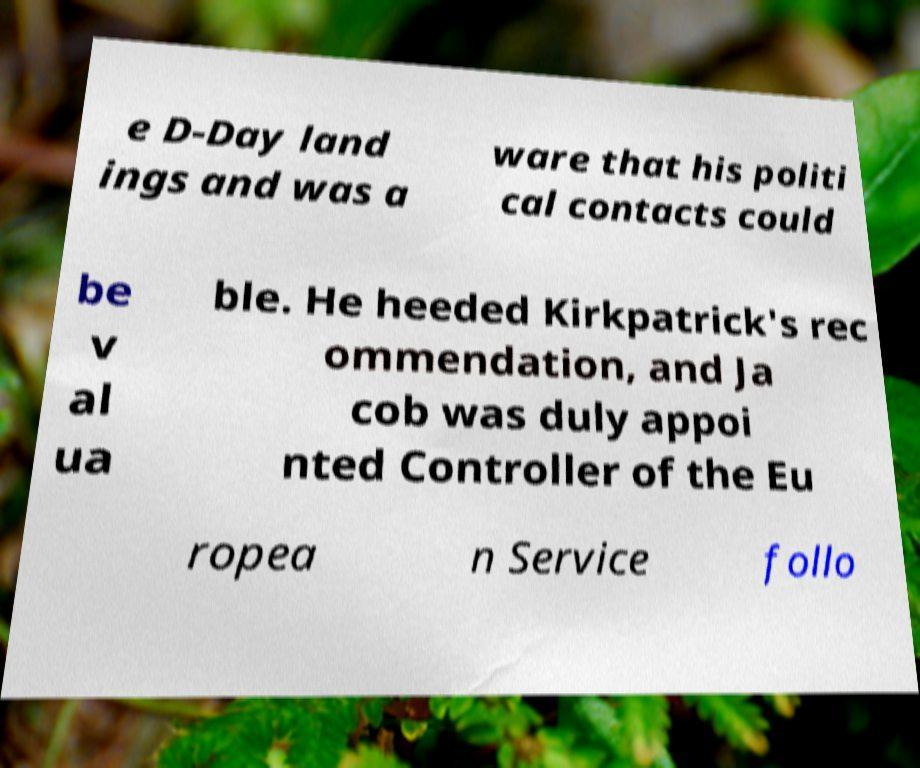Can you read and provide the text displayed in the image?This photo seems to have some interesting text. Can you extract and type it out for me? e D-Day land ings and was a ware that his politi cal contacts could be v al ua ble. He heeded Kirkpatrick's rec ommendation, and Ja cob was duly appoi nted Controller of the Eu ropea n Service follo 